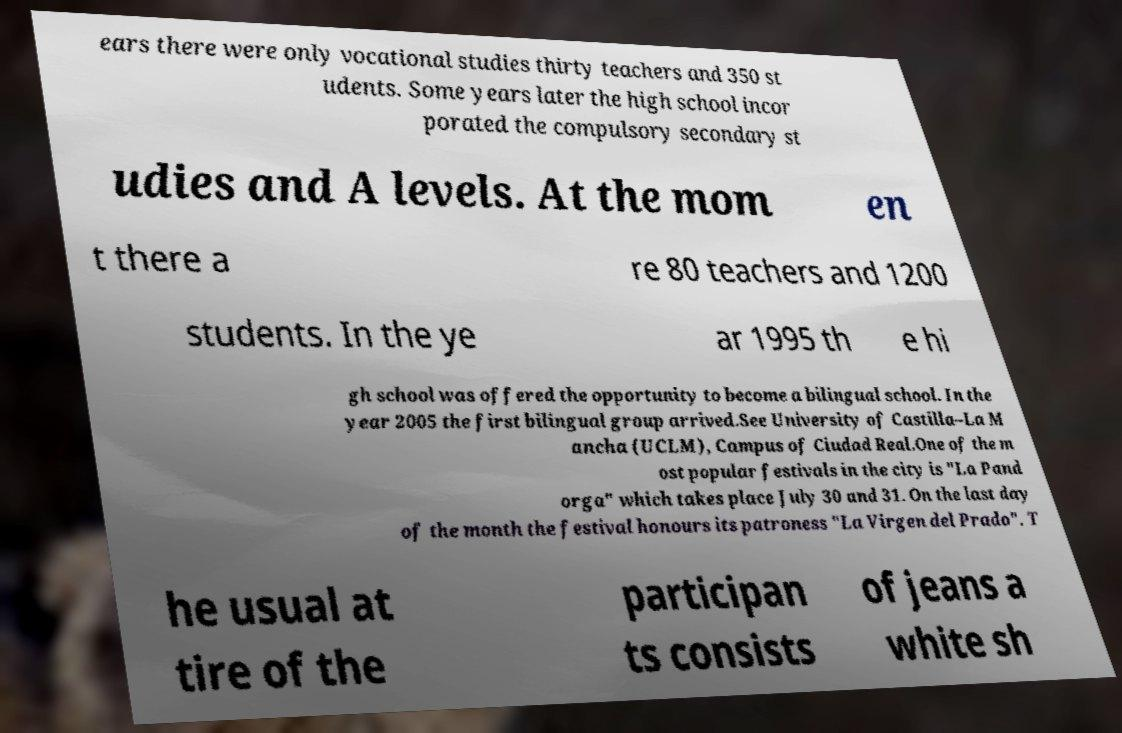Could you assist in decoding the text presented in this image and type it out clearly? ears there were only vocational studies thirty teachers and 350 st udents. Some years later the high school incor porated the compulsory secondary st udies and A levels. At the mom en t there a re 80 teachers and 1200 students. In the ye ar 1995 th e hi gh school was offered the opportunity to become a bilingual school. In the year 2005 the first bilingual group arrived.See University of Castilla–La M ancha (UCLM), Campus of Ciudad Real.One of the m ost popular festivals in the city is "La Pand orga" which takes place July 30 and 31. On the last day of the month the festival honours its patroness "La Virgen del Prado". T he usual at tire of the participan ts consists of jeans a white sh 